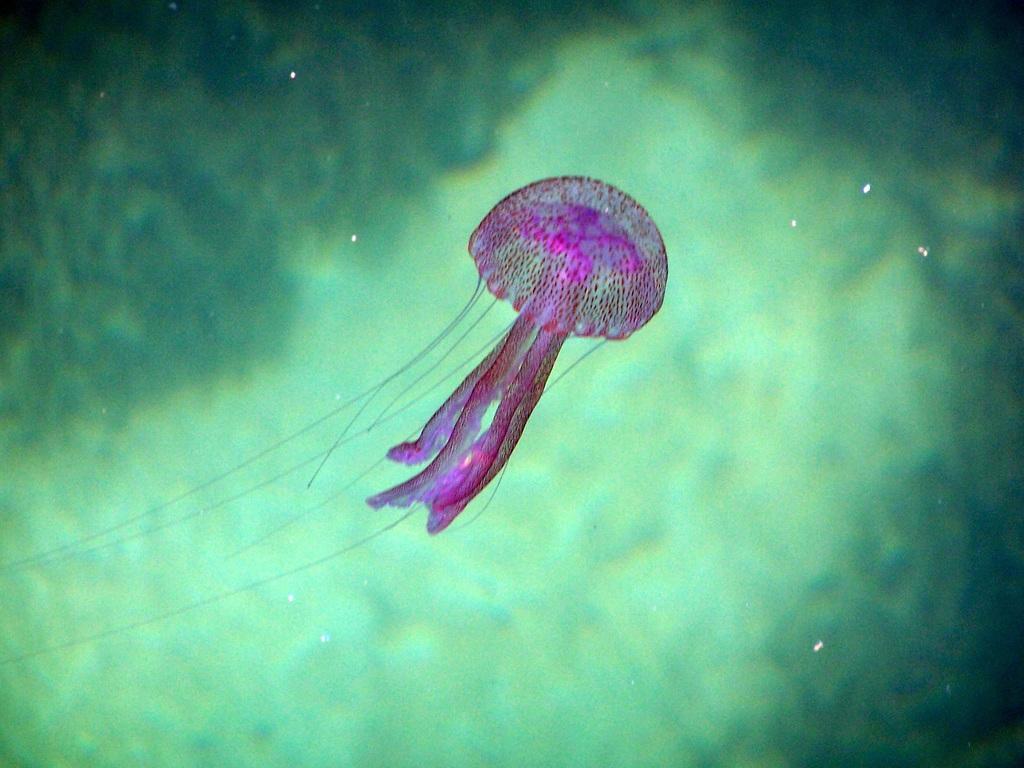Could you give a brief overview of what you see in this image? There is a jellyfish in the water of an ocean. The background is green in color. 